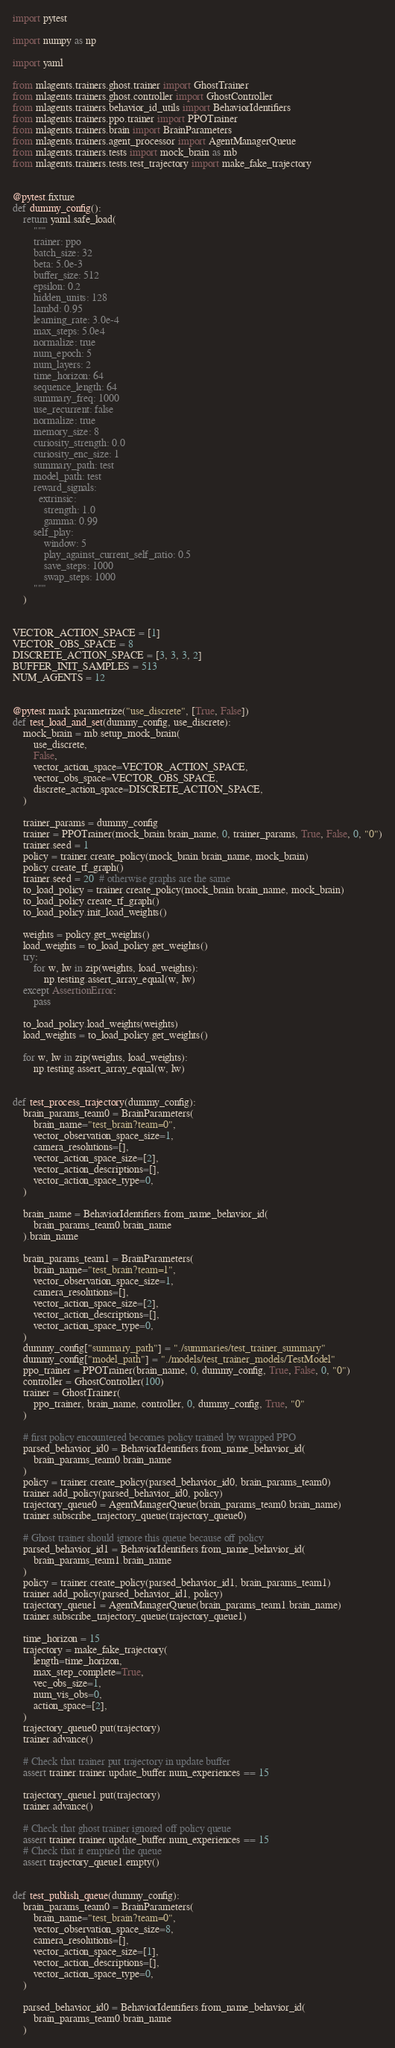<code> <loc_0><loc_0><loc_500><loc_500><_Python_>import pytest

import numpy as np

import yaml

from mlagents.trainers.ghost.trainer import GhostTrainer
from mlagents.trainers.ghost.controller import GhostController
from mlagents.trainers.behavior_id_utils import BehaviorIdentifiers
from mlagents.trainers.ppo.trainer import PPOTrainer
from mlagents.trainers.brain import BrainParameters
from mlagents.trainers.agent_processor import AgentManagerQueue
from mlagents.trainers.tests import mock_brain as mb
from mlagents.trainers.tests.test_trajectory import make_fake_trajectory


@pytest.fixture
def dummy_config():
    return yaml.safe_load(
        """
        trainer: ppo
        batch_size: 32
        beta: 5.0e-3
        buffer_size: 512
        epsilon: 0.2
        hidden_units: 128
        lambd: 0.95
        learning_rate: 3.0e-4
        max_steps: 5.0e4
        normalize: true
        num_epoch: 5
        num_layers: 2
        time_horizon: 64
        sequence_length: 64
        summary_freq: 1000
        use_recurrent: false
        normalize: true
        memory_size: 8
        curiosity_strength: 0.0
        curiosity_enc_size: 1
        summary_path: test
        model_path: test
        reward_signals:
          extrinsic:
            strength: 1.0
            gamma: 0.99
        self_play:
            window: 5
            play_against_current_self_ratio: 0.5
            save_steps: 1000
            swap_steps: 1000
        """
    )


VECTOR_ACTION_SPACE = [1]
VECTOR_OBS_SPACE = 8
DISCRETE_ACTION_SPACE = [3, 3, 3, 2]
BUFFER_INIT_SAMPLES = 513
NUM_AGENTS = 12


@pytest.mark.parametrize("use_discrete", [True, False])
def test_load_and_set(dummy_config, use_discrete):
    mock_brain = mb.setup_mock_brain(
        use_discrete,
        False,
        vector_action_space=VECTOR_ACTION_SPACE,
        vector_obs_space=VECTOR_OBS_SPACE,
        discrete_action_space=DISCRETE_ACTION_SPACE,
    )

    trainer_params = dummy_config
    trainer = PPOTrainer(mock_brain.brain_name, 0, trainer_params, True, False, 0, "0")
    trainer.seed = 1
    policy = trainer.create_policy(mock_brain.brain_name, mock_brain)
    policy.create_tf_graph()
    trainer.seed = 20  # otherwise graphs are the same
    to_load_policy = trainer.create_policy(mock_brain.brain_name, mock_brain)
    to_load_policy.create_tf_graph()
    to_load_policy.init_load_weights()

    weights = policy.get_weights()
    load_weights = to_load_policy.get_weights()
    try:
        for w, lw in zip(weights, load_weights):
            np.testing.assert_array_equal(w, lw)
    except AssertionError:
        pass

    to_load_policy.load_weights(weights)
    load_weights = to_load_policy.get_weights()

    for w, lw in zip(weights, load_weights):
        np.testing.assert_array_equal(w, lw)


def test_process_trajectory(dummy_config):
    brain_params_team0 = BrainParameters(
        brain_name="test_brain?team=0",
        vector_observation_space_size=1,
        camera_resolutions=[],
        vector_action_space_size=[2],
        vector_action_descriptions=[],
        vector_action_space_type=0,
    )

    brain_name = BehaviorIdentifiers.from_name_behavior_id(
        brain_params_team0.brain_name
    ).brain_name

    brain_params_team1 = BrainParameters(
        brain_name="test_brain?team=1",
        vector_observation_space_size=1,
        camera_resolutions=[],
        vector_action_space_size=[2],
        vector_action_descriptions=[],
        vector_action_space_type=0,
    )
    dummy_config["summary_path"] = "./summaries/test_trainer_summary"
    dummy_config["model_path"] = "./models/test_trainer_models/TestModel"
    ppo_trainer = PPOTrainer(brain_name, 0, dummy_config, True, False, 0, "0")
    controller = GhostController(100)
    trainer = GhostTrainer(
        ppo_trainer, brain_name, controller, 0, dummy_config, True, "0"
    )

    # first policy encountered becomes policy trained by wrapped PPO
    parsed_behavior_id0 = BehaviorIdentifiers.from_name_behavior_id(
        brain_params_team0.brain_name
    )
    policy = trainer.create_policy(parsed_behavior_id0, brain_params_team0)
    trainer.add_policy(parsed_behavior_id0, policy)
    trajectory_queue0 = AgentManagerQueue(brain_params_team0.brain_name)
    trainer.subscribe_trajectory_queue(trajectory_queue0)

    # Ghost trainer should ignore this queue because off policy
    parsed_behavior_id1 = BehaviorIdentifiers.from_name_behavior_id(
        brain_params_team1.brain_name
    )
    policy = trainer.create_policy(parsed_behavior_id1, brain_params_team1)
    trainer.add_policy(parsed_behavior_id1, policy)
    trajectory_queue1 = AgentManagerQueue(brain_params_team1.brain_name)
    trainer.subscribe_trajectory_queue(trajectory_queue1)

    time_horizon = 15
    trajectory = make_fake_trajectory(
        length=time_horizon,
        max_step_complete=True,
        vec_obs_size=1,
        num_vis_obs=0,
        action_space=[2],
    )
    trajectory_queue0.put(trajectory)
    trainer.advance()

    # Check that trainer put trajectory in update buffer
    assert trainer.trainer.update_buffer.num_experiences == 15

    trajectory_queue1.put(trajectory)
    trainer.advance()

    # Check that ghost trainer ignored off policy queue
    assert trainer.trainer.update_buffer.num_experiences == 15
    # Check that it emptied the queue
    assert trajectory_queue1.empty()


def test_publish_queue(dummy_config):
    brain_params_team0 = BrainParameters(
        brain_name="test_brain?team=0",
        vector_observation_space_size=8,
        camera_resolutions=[],
        vector_action_space_size=[1],
        vector_action_descriptions=[],
        vector_action_space_type=0,
    )

    parsed_behavior_id0 = BehaviorIdentifiers.from_name_behavior_id(
        brain_params_team0.brain_name
    )
</code> 